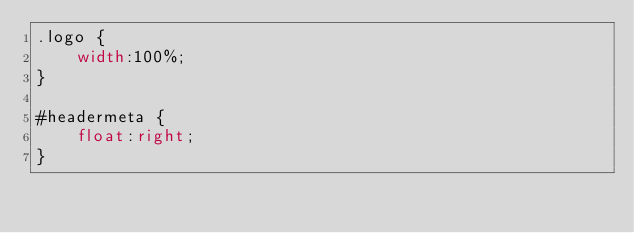Convert code to text. <code><loc_0><loc_0><loc_500><loc_500><_CSS_>.logo { 
    width:100%; 
}

#headermeta {
    float:right;
}</code> 